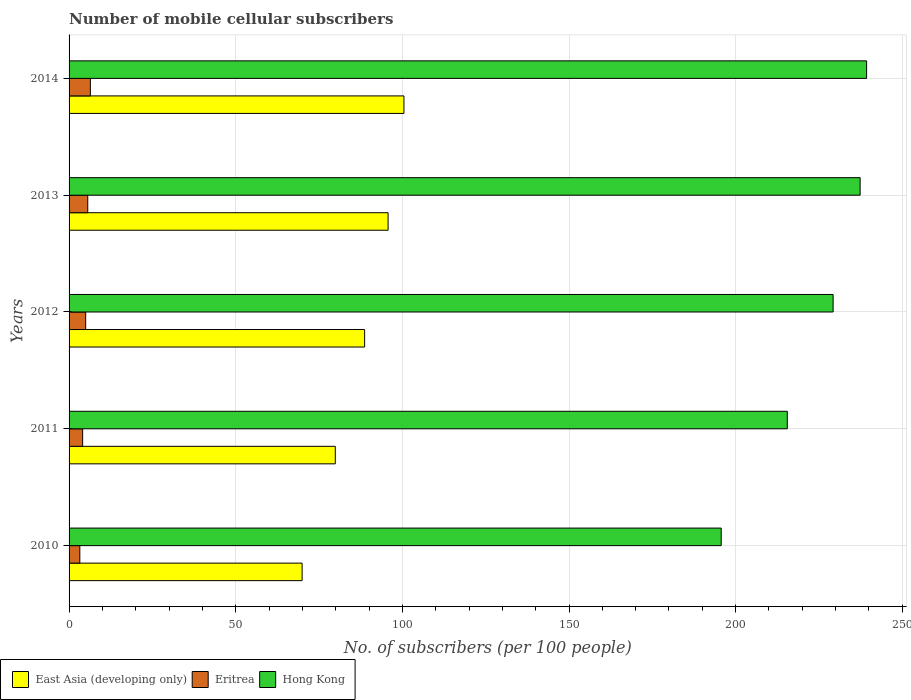What is the number of mobile cellular subscribers in Hong Kong in 2014?
Provide a short and direct response. 239.3. Across all years, what is the maximum number of mobile cellular subscribers in Eritrea?
Give a very brief answer. 6.39. Across all years, what is the minimum number of mobile cellular subscribers in Hong Kong?
Your answer should be very brief. 195.67. In which year was the number of mobile cellular subscribers in Hong Kong maximum?
Make the answer very short. 2014. What is the total number of mobile cellular subscribers in Eritrea in the graph?
Offer a very short reply. 24.27. What is the difference between the number of mobile cellular subscribers in Hong Kong in 2012 and that in 2013?
Provide a succinct answer. -8.11. What is the difference between the number of mobile cellular subscribers in East Asia (developing only) in 2014 and the number of mobile cellular subscribers in Eritrea in 2013?
Provide a short and direct response. 94.87. What is the average number of mobile cellular subscribers in Eritrea per year?
Keep it short and to the point. 4.85. In the year 2010, what is the difference between the number of mobile cellular subscribers in Hong Kong and number of mobile cellular subscribers in Eritrea?
Provide a short and direct response. 192.44. In how many years, is the number of mobile cellular subscribers in Eritrea greater than 150 ?
Give a very brief answer. 0. What is the ratio of the number of mobile cellular subscribers in Hong Kong in 2011 to that in 2013?
Your response must be concise. 0.91. What is the difference between the highest and the second highest number of mobile cellular subscribers in Hong Kong?
Provide a succinct answer. 1.95. What is the difference between the highest and the lowest number of mobile cellular subscribers in Eritrea?
Offer a very short reply. 3.16. What does the 1st bar from the top in 2013 represents?
Keep it short and to the point. Hong Kong. What does the 2nd bar from the bottom in 2013 represents?
Offer a terse response. Eritrea. How many bars are there?
Ensure brevity in your answer.  15. How are the legend labels stacked?
Offer a very short reply. Horizontal. What is the title of the graph?
Give a very brief answer. Number of mobile cellular subscribers. Does "Middle East & North Africa (all income levels)" appear as one of the legend labels in the graph?
Ensure brevity in your answer.  No. What is the label or title of the X-axis?
Your answer should be compact. No. of subscribers (per 100 people). What is the No. of subscribers (per 100 people) of East Asia (developing only) in 2010?
Keep it short and to the point. 69.92. What is the No. of subscribers (per 100 people) of Eritrea in 2010?
Offer a very short reply. 3.23. What is the No. of subscribers (per 100 people) of Hong Kong in 2010?
Keep it short and to the point. 195.67. What is the No. of subscribers (per 100 people) in East Asia (developing only) in 2011?
Provide a short and direct response. 79.88. What is the No. of subscribers (per 100 people) of Eritrea in 2011?
Make the answer very short. 4.08. What is the No. of subscribers (per 100 people) of Hong Kong in 2011?
Make the answer very short. 215.5. What is the No. of subscribers (per 100 people) of East Asia (developing only) in 2012?
Your answer should be very brief. 88.68. What is the No. of subscribers (per 100 people) in Eritrea in 2012?
Ensure brevity in your answer.  4.98. What is the No. of subscribers (per 100 people) in Hong Kong in 2012?
Offer a very short reply. 229.24. What is the No. of subscribers (per 100 people) of East Asia (developing only) in 2013?
Ensure brevity in your answer.  95.72. What is the No. of subscribers (per 100 people) of Eritrea in 2013?
Offer a terse response. 5.6. What is the No. of subscribers (per 100 people) in Hong Kong in 2013?
Your response must be concise. 237.35. What is the No. of subscribers (per 100 people) of East Asia (developing only) in 2014?
Offer a terse response. 100.48. What is the No. of subscribers (per 100 people) of Eritrea in 2014?
Ensure brevity in your answer.  6.39. What is the No. of subscribers (per 100 people) in Hong Kong in 2014?
Provide a short and direct response. 239.3. Across all years, what is the maximum No. of subscribers (per 100 people) in East Asia (developing only)?
Offer a terse response. 100.48. Across all years, what is the maximum No. of subscribers (per 100 people) of Eritrea?
Your answer should be very brief. 6.39. Across all years, what is the maximum No. of subscribers (per 100 people) in Hong Kong?
Your response must be concise. 239.3. Across all years, what is the minimum No. of subscribers (per 100 people) of East Asia (developing only)?
Keep it short and to the point. 69.92. Across all years, what is the minimum No. of subscribers (per 100 people) in Eritrea?
Provide a succinct answer. 3.23. Across all years, what is the minimum No. of subscribers (per 100 people) in Hong Kong?
Your response must be concise. 195.67. What is the total No. of subscribers (per 100 people) of East Asia (developing only) in the graph?
Your response must be concise. 434.68. What is the total No. of subscribers (per 100 people) in Eritrea in the graph?
Your response must be concise. 24.27. What is the total No. of subscribers (per 100 people) in Hong Kong in the graph?
Your answer should be very brief. 1117.07. What is the difference between the No. of subscribers (per 100 people) of East Asia (developing only) in 2010 and that in 2011?
Offer a very short reply. -9.95. What is the difference between the No. of subscribers (per 100 people) in Eritrea in 2010 and that in 2011?
Ensure brevity in your answer.  -0.85. What is the difference between the No. of subscribers (per 100 people) in Hong Kong in 2010 and that in 2011?
Make the answer very short. -19.83. What is the difference between the No. of subscribers (per 100 people) in East Asia (developing only) in 2010 and that in 2012?
Provide a short and direct response. -18.76. What is the difference between the No. of subscribers (per 100 people) of Eritrea in 2010 and that in 2012?
Offer a terse response. -1.75. What is the difference between the No. of subscribers (per 100 people) of Hong Kong in 2010 and that in 2012?
Offer a very short reply. -33.58. What is the difference between the No. of subscribers (per 100 people) of East Asia (developing only) in 2010 and that in 2013?
Your answer should be compact. -25.8. What is the difference between the No. of subscribers (per 100 people) in Eritrea in 2010 and that in 2013?
Ensure brevity in your answer.  -2.38. What is the difference between the No. of subscribers (per 100 people) in Hong Kong in 2010 and that in 2013?
Your response must be concise. -41.68. What is the difference between the No. of subscribers (per 100 people) of East Asia (developing only) in 2010 and that in 2014?
Your response must be concise. -30.55. What is the difference between the No. of subscribers (per 100 people) in Eritrea in 2010 and that in 2014?
Your answer should be compact. -3.16. What is the difference between the No. of subscribers (per 100 people) of Hong Kong in 2010 and that in 2014?
Your answer should be very brief. -43.63. What is the difference between the No. of subscribers (per 100 people) in East Asia (developing only) in 2011 and that in 2012?
Your response must be concise. -8.8. What is the difference between the No. of subscribers (per 100 people) in Eritrea in 2011 and that in 2012?
Offer a terse response. -0.9. What is the difference between the No. of subscribers (per 100 people) of Hong Kong in 2011 and that in 2012?
Provide a short and direct response. -13.74. What is the difference between the No. of subscribers (per 100 people) in East Asia (developing only) in 2011 and that in 2013?
Ensure brevity in your answer.  -15.84. What is the difference between the No. of subscribers (per 100 people) of Eritrea in 2011 and that in 2013?
Ensure brevity in your answer.  -1.52. What is the difference between the No. of subscribers (per 100 people) of Hong Kong in 2011 and that in 2013?
Ensure brevity in your answer.  -21.85. What is the difference between the No. of subscribers (per 100 people) in East Asia (developing only) in 2011 and that in 2014?
Provide a succinct answer. -20.6. What is the difference between the No. of subscribers (per 100 people) in Eritrea in 2011 and that in 2014?
Keep it short and to the point. -2.31. What is the difference between the No. of subscribers (per 100 people) of Hong Kong in 2011 and that in 2014?
Offer a terse response. -23.79. What is the difference between the No. of subscribers (per 100 people) in East Asia (developing only) in 2012 and that in 2013?
Make the answer very short. -7.04. What is the difference between the No. of subscribers (per 100 people) of Eritrea in 2012 and that in 2013?
Give a very brief answer. -0.62. What is the difference between the No. of subscribers (per 100 people) of Hong Kong in 2012 and that in 2013?
Keep it short and to the point. -8.11. What is the difference between the No. of subscribers (per 100 people) of East Asia (developing only) in 2012 and that in 2014?
Make the answer very short. -11.8. What is the difference between the No. of subscribers (per 100 people) of Eritrea in 2012 and that in 2014?
Offer a very short reply. -1.41. What is the difference between the No. of subscribers (per 100 people) in Hong Kong in 2012 and that in 2014?
Provide a short and direct response. -10.05. What is the difference between the No. of subscribers (per 100 people) in East Asia (developing only) in 2013 and that in 2014?
Your answer should be compact. -4.76. What is the difference between the No. of subscribers (per 100 people) of Eritrea in 2013 and that in 2014?
Keep it short and to the point. -0.78. What is the difference between the No. of subscribers (per 100 people) of Hong Kong in 2013 and that in 2014?
Offer a terse response. -1.95. What is the difference between the No. of subscribers (per 100 people) in East Asia (developing only) in 2010 and the No. of subscribers (per 100 people) in Eritrea in 2011?
Offer a terse response. 65.85. What is the difference between the No. of subscribers (per 100 people) of East Asia (developing only) in 2010 and the No. of subscribers (per 100 people) of Hong Kong in 2011?
Your response must be concise. -145.58. What is the difference between the No. of subscribers (per 100 people) in Eritrea in 2010 and the No. of subscribers (per 100 people) in Hong Kong in 2011?
Offer a very short reply. -212.28. What is the difference between the No. of subscribers (per 100 people) of East Asia (developing only) in 2010 and the No. of subscribers (per 100 people) of Eritrea in 2012?
Provide a succinct answer. 64.94. What is the difference between the No. of subscribers (per 100 people) of East Asia (developing only) in 2010 and the No. of subscribers (per 100 people) of Hong Kong in 2012?
Provide a succinct answer. -159.32. What is the difference between the No. of subscribers (per 100 people) in Eritrea in 2010 and the No. of subscribers (per 100 people) in Hong Kong in 2012?
Offer a very short reply. -226.02. What is the difference between the No. of subscribers (per 100 people) of East Asia (developing only) in 2010 and the No. of subscribers (per 100 people) of Eritrea in 2013?
Your answer should be compact. 64.32. What is the difference between the No. of subscribers (per 100 people) of East Asia (developing only) in 2010 and the No. of subscribers (per 100 people) of Hong Kong in 2013?
Your answer should be compact. -167.43. What is the difference between the No. of subscribers (per 100 people) in Eritrea in 2010 and the No. of subscribers (per 100 people) in Hong Kong in 2013?
Provide a succinct answer. -234.12. What is the difference between the No. of subscribers (per 100 people) in East Asia (developing only) in 2010 and the No. of subscribers (per 100 people) in Eritrea in 2014?
Your answer should be very brief. 63.54. What is the difference between the No. of subscribers (per 100 people) of East Asia (developing only) in 2010 and the No. of subscribers (per 100 people) of Hong Kong in 2014?
Your answer should be compact. -169.37. What is the difference between the No. of subscribers (per 100 people) in Eritrea in 2010 and the No. of subscribers (per 100 people) in Hong Kong in 2014?
Your answer should be very brief. -236.07. What is the difference between the No. of subscribers (per 100 people) of East Asia (developing only) in 2011 and the No. of subscribers (per 100 people) of Eritrea in 2012?
Provide a succinct answer. 74.9. What is the difference between the No. of subscribers (per 100 people) of East Asia (developing only) in 2011 and the No. of subscribers (per 100 people) of Hong Kong in 2012?
Provide a short and direct response. -149.37. What is the difference between the No. of subscribers (per 100 people) of Eritrea in 2011 and the No. of subscribers (per 100 people) of Hong Kong in 2012?
Your response must be concise. -225.17. What is the difference between the No. of subscribers (per 100 people) in East Asia (developing only) in 2011 and the No. of subscribers (per 100 people) in Eritrea in 2013?
Your response must be concise. 74.28. What is the difference between the No. of subscribers (per 100 people) of East Asia (developing only) in 2011 and the No. of subscribers (per 100 people) of Hong Kong in 2013?
Your answer should be compact. -157.47. What is the difference between the No. of subscribers (per 100 people) in Eritrea in 2011 and the No. of subscribers (per 100 people) in Hong Kong in 2013?
Ensure brevity in your answer.  -233.27. What is the difference between the No. of subscribers (per 100 people) in East Asia (developing only) in 2011 and the No. of subscribers (per 100 people) in Eritrea in 2014?
Your answer should be very brief. 73.49. What is the difference between the No. of subscribers (per 100 people) in East Asia (developing only) in 2011 and the No. of subscribers (per 100 people) in Hong Kong in 2014?
Your response must be concise. -159.42. What is the difference between the No. of subscribers (per 100 people) of Eritrea in 2011 and the No. of subscribers (per 100 people) of Hong Kong in 2014?
Keep it short and to the point. -235.22. What is the difference between the No. of subscribers (per 100 people) in East Asia (developing only) in 2012 and the No. of subscribers (per 100 people) in Eritrea in 2013?
Your answer should be very brief. 83.08. What is the difference between the No. of subscribers (per 100 people) in East Asia (developing only) in 2012 and the No. of subscribers (per 100 people) in Hong Kong in 2013?
Offer a terse response. -148.67. What is the difference between the No. of subscribers (per 100 people) of Eritrea in 2012 and the No. of subscribers (per 100 people) of Hong Kong in 2013?
Make the answer very short. -232.37. What is the difference between the No. of subscribers (per 100 people) of East Asia (developing only) in 2012 and the No. of subscribers (per 100 people) of Eritrea in 2014?
Your answer should be very brief. 82.29. What is the difference between the No. of subscribers (per 100 people) in East Asia (developing only) in 2012 and the No. of subscribers (per 100 people) in Hong Kong in 2014?
Offer a very short reply. -150.62. What is the difference between the No. of subscribers (per 100 people) in Eritrea in 2012 and the No. of subscribers (per 100 people) in Hong Kong in 2014?
Ensure brevity in your answer.  -234.32. What is the difference between the No. of subscribers (per 100 people) of East Asia (developing only) in 2013 and the No. of subscribers (per 100 people) of Eritrea in 2014?
Make the answer very short. 89.33. What is the difference between the No. of subscribers (per 100 people) in East Asia (developing only) in 2013 and the No. of subscribers (per 100 people) in Hong Kong in 2014?
Provide a short and direct response. -143.58. What is the difference between the No. of subscribers (per 100 people) of Eritrea in 2013 and the No. of subscribers (per 100 people) of Hong Kong in 2014?
Your answer should be very brief. -233.69. What is the average No. of subscribers (per 100 people) in East Asia (developing only) per year?
Provide a short and direct response. 86.94. What is the average No. of subscribers (per 100 people) in Eritrea per year?
Ensure brevity in your answer.  4.85. What is the average No. of subscribers (per 100 people) in Hong Kong per year?
Your answer should be compact. 223.41. In the year 2010, what is the difference between the No. of subscribers (per 100 people) in East Asia (developing only) and No. of subscribers (per 100 people) in Eritrea?
Offer a very short reply. 66.7. In the year 2010, what is the difference between the No. of subscribers (per 100 people) in East Asia (developing only) and No. of subscribers (per 100 people) in Hong Kong?
Provide a succinct answer. -125.75. In the year 2010, what is the difference between the No. of subscribers (per 100 people) of Eritrea and No. of subscribers (per 100 people) of Hong Kong?
Your response must be concise. -192.44. In the year 2011, what is the difference between the No. of subscribers (per 100 people) in East Asia (developing only) and No. of subscribers (per 100 people) in Eritrea?
Provide a short and direct response. 75.8. In the year 2011, what is the difference between the No. of subscribers (per 100 people) in East Asia (developing only) and No. of subscribers (per 100 people) in Hong Kong?
Your answer should be very brief. -135.63. In the year 2011, what is the difference between the No. of subscribers (per 100 people) of Eritrea and No. of subscribers (per 100 people) of Hong Kong?
Provide a short and direct response. -211.43. In the year 2012, what is the difference between the No. of subscribers (per 100 people) in East Asia (developing only) and No. of subscribers (per 100 people) in Eritrea?
Your answer should be very brief. 83.7. In the year 2012, what is the difference between the No. of subscribers (per 100 people) in East Asia (developing only) and No. of subscribers (per 100 people) in Hong Kong?
Ensure brevity in your answer.  -140.56. In the year 2012, what is the difference between the No. of subscribers (per 100 people) in Eritrea and No. of subscribers (per 100 people) in Hong Kong?
Your answer should be compact. -224.27. In the year 2013, what is the difference between the No. of subscribers (per 100 people) in East Asia (developing only) and No. of subscribers (per 100 people) in Eritrea?
Ensure brevity in your answer.  90.12. In the year 2013, what is the difference between the No. of subscribers (per 100 people) of East Asia (developing only) and No. of subscribers (per 100 people) of Hong Kong?
Provide a succinct answer. -141.63. In the year 2013, what is the difference between the No. of subscribers (per 100 people) in Eritrea and No. of subscribers (per 100 people) in Hong Kong?
Give a very brief answer. -231.75. In the year 2014, what is the difference between the No. of subscribers (per 100 people) of East Asia (developing only) and No. of subscribers (per 100 people) of Eritrea?
Keep it short and to the point. 94.09. In the year 2014, what is the difference between the No. of subscribers (per 100 people) in East Asia (developing only) and No. of subscribers (per 100 people) in Hong Kong?
Keep it short and to the point. -138.82. In the year 2014, what is the difference between the No. of subscribers (per 100 people) of Eritrea and No. of subscribers (per 100 people) of Hong Kong?
Your answer should be compact. -232.91. What is the ratio of the No. of subscribers (per 100 people) of East Asia (developing only) in 2010 to that in 2011?
Ensure brevity in your answer.  0.88. What is the ratio of the No. of subscribers (per 100 people) of Eritrea in 2010 to that in 2011?
Give a very brief answer. 0.79. What is the ratio of the No. of subscribers (per 100 people) in Hong Kong in 2010 to that in 2011?
Your response must be concise. 0.91. What is the ratio of the No. of subscribers (per 100 people) of East Asia (developing only) in 2010 to that in 2012?
Keep it short and to the point. 0.79. What is the ratio of the No. of subscribers (per 100 people) in Eritrea in 2010 to that in 2012?
Provide a succinct answer. 0.65. What is the ratio of the No. of subscribers (per 100 people) of Hong Kong in 2010 to that in 2012?
Give a very brief answer. 0.85. What is the ratio of the No. of subscribers (per 100 people) in East Asia (developing only) in 2010 to that in 2013?
Ensure brevity in your answer.  0.73. What is the ratio of the No. of subscribers (per 100 people) of Eritrea in 2010 to that in 2013?
Provide a succinct answer. 0.58. What is the ratio of the No. of subscribers (per 100 people) in Hong Kong in 2010 to that in 2013?
Provide a short and direct response. 0.82. What is the ratio of the No. of subscribers (per 100 people) of East Asia (developing only) in 2010 to that in 2014?
Make the answer very short. 0.7. What is the ratio of the No. of subscribers (per 100 people) of Eritrea in 2010 to that in 2014?
Your response must be concise. 0.51. What is the ratio of the No. of subscribers (per 100 people) of Hong Kong in 2010 to that in 2014?
Your answer should be very brief. 0.82. What is the ratio of the No. of subscribers (per 100 people) of East Asia (developing only) in 2011 to that in 2012?
Your answer should be compact. 0.9. What is the ratio of the No. of subscribers (per 100 people) in Eritrea in 2011 to that in 2012?
Give a very brief answer. 0.82. What is the ratio of the No. of subscribers (per 100 people) in Hong Kong in 2011 to that in 2012?
Give a very brief answer. 0.94. What is the ratio of the No. of subscribers (per 100 people) of East Asia (developing only) in 2011 to that in 2013?
Your answer should be very brief. 0.83. What is the ratio of the No. of subscribers (per 100 people) in Eritrea in 2011 to that in 2013?
Provide a succinct answer. 0.73. What is the ratio of the No. of subscribers (per 100 people) of Hong Kong in 2011 to that in 2013?
Make the answer very short. 0.91. What is the ratio of the No. of subscribers (per 100 people) in East Asia (developing only) in 2011 to that in 2014?
Keep it short and to the point. 0.8. What is the ratio of the No. of subscribers (per 100 people) in Eritrea in 2011 to that in 2014?
Make the answer very short. 0.64. What is the ratio of the No. of subscribers (per 100 people) in Hong Kong in 2011 to that in 2014?
Give a very brief answer. 0.9. What is the ratio of the No. of subscribers (per 100 people) in East Asia (developing only) in 2012 to that in 2013?
Your response must be concise. 0.93. What is the ratio of the No. of subscribers (per 100 people) of Eritrea in 2012 to that in 2013?
Provide a succinct answer. 0.89. What is the ratio of the No. of subscribers (per 100 people) of Hong Kong in 2012 to that in 2013?
Keep it short and to the point. 0.97. What is the ratio of the No. of subscribers (per 100 people) of East Asia (developing only) in 2012 to that in 2014?
Your response must be concise. 0.88. What is the ratio of the No. of subscribers (per 100 people) of Eritrea in 2012 to that in 2014?
Your answer should be compact. 0.78. What is the ratio of the No. of subscribers (per 100 people) in Hong Kong in 2012 to that in 2014?
Make the answer very short. 0.96. What is the ratio of the No. of subscribers (per 100 people) of East Asia (developing only) in 2013 to that in 2014?
Your answer should be very brief. 0.95. What is the ratio of the No. of subscribers (per 100 people) in Eritrea in 2013 to that in 2014?
Make the answer very short. 0.88. What is the difference between the highest and the second highest No. of subscribers (per 100 people) of East Asia (developing only)?
Offer a terse response. 4.76. What is the difference between the highest and the second highest No. of subscribers (per 100 people) of Eritrea?
Offer a terse response. 0.78. What is the difference between the highest and the second highest No. of subscribers (per 100 people) in Hong Kong?
Provide a short and direct response. 1.95. What is the difference between the highest and the lowest No. of subscribers (per 100 people) in East Asia (developing only)?
Your answer should be compact. 30.55. What is the difference between the highest and the lowest No. of subscribers (per 100 people) in Eritrea?
Your answer should be very brief. 3.16. What is the difference between the highest and the lowest No. of subscribers (per 100 people) in Hong Kong?
Make the answer very short. 43.63. 